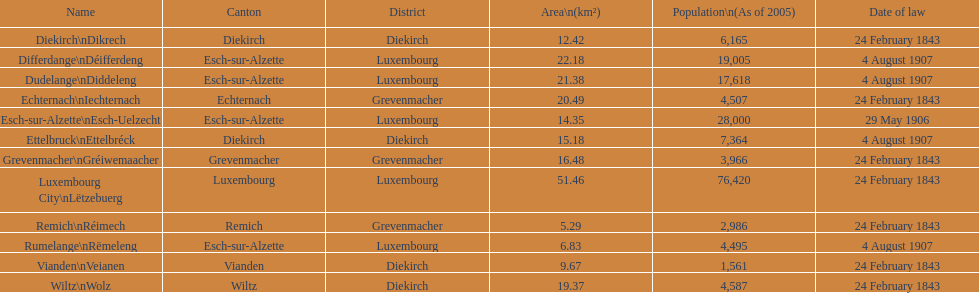What canton is the most populated? Luxembourg. 